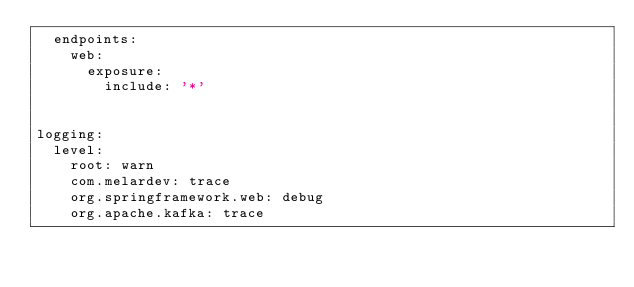Convert code to text. <code><loc_0><loc_0><loc_500><loc_500><_YAML_>  endpoints:
    web:
      exposure:
        include: '*'


logging:
  level:
    root: warn
    com.melardev: trace
    org.springframework.web: debug
    org.apache.kafka: trace

</code> 